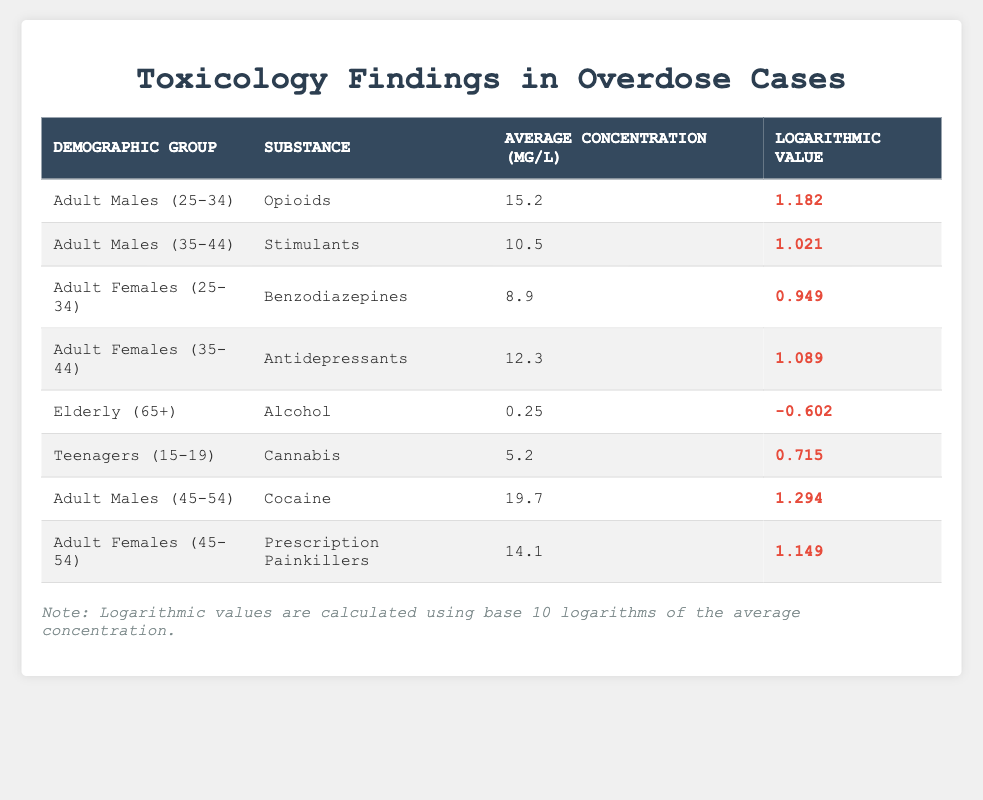What is the average concentration of Opioids in Adult Males (25-34)? The table shows the average concentration of Opioids for the demographic group of Adult Males (25-34) is listed as 15.2 mg/L.
Answer: 15.2 mg/L What is the logarithmic value for Alcohol in the Elderly (65+)? The table indicates that the logarithmic value for Alcohol in the demographic group of Elderly (65+) is -0.602.
Answer: -0.602 Is the average concentration of Cocaine higher than that of Prescription Painkillers? The average concentration of Cocaine for Adult Males (45-54) is 19.7 mg/L, while for Adult Females (45-54) it is 14.1 mg/L. Since 19.7 > 14.1, the statement is true.
Answer: Yes What is the difference in logarithmic values between Adult Males (25-34) and Adult Females (35-44)? The logarithmic value for Adult Males (25-34) is 1.182, and for Adult Females (35-44), it is 1.089. The difference is 1.182 - 1.089 = 0.093.
Answer: 0.093 Which demographic group has the highest average concentration for any substance listed? Looking through the table, Adult Males (45-54) have the highest average concentration with Cocaine at 19.7 mg/L.
Answer: Adult Males (45-54) What is the average concentration of substances for Teenagers (15-19) and Adult Females (25-34)? For Teenagers (15-19), the average concentration of Cannabis is 5.2 mg/L. For Adult Females (25-34), the average concentration of Benzodiazepines is 8.9 mg/L. Their combined average is (5.2 + 8.9) / 2 = 7.05 mg/L.
Answer: 7.05 mg/L Does the logarithmic value for Benzodiazepines in Adult Females (25-34) indicate a higher concentration compared to Alcohol in the Elderly (65+)? The logarithmic value for Benzodiazepines is 0.949, while for Alcohol it is -0.602. Since 0.949 > -0.602, this statement is true.
Answer: Yes What is the sum of the average concentrations for all the substances listed? The average concentrations are 15.2 (Opioids) + 10.5 (Stimulants) + 8.9 (Benzodiazepines) + 12.3 (Antidepressants) + 0.25 (Alcohol) + 5.2 (Cannabis) + 19.7 (Cocaine) + 14.1 (Prescription Painkillers) = 81.05 mg/L.
Answer: 81.05 mg/L Which substance has the lowest average concentration in the table? Alcohol in the Elderly (65+) has the lowest average concentration, recorded at 0.25 mg/L.
Answer: Alcohol 0.25 mg/L 